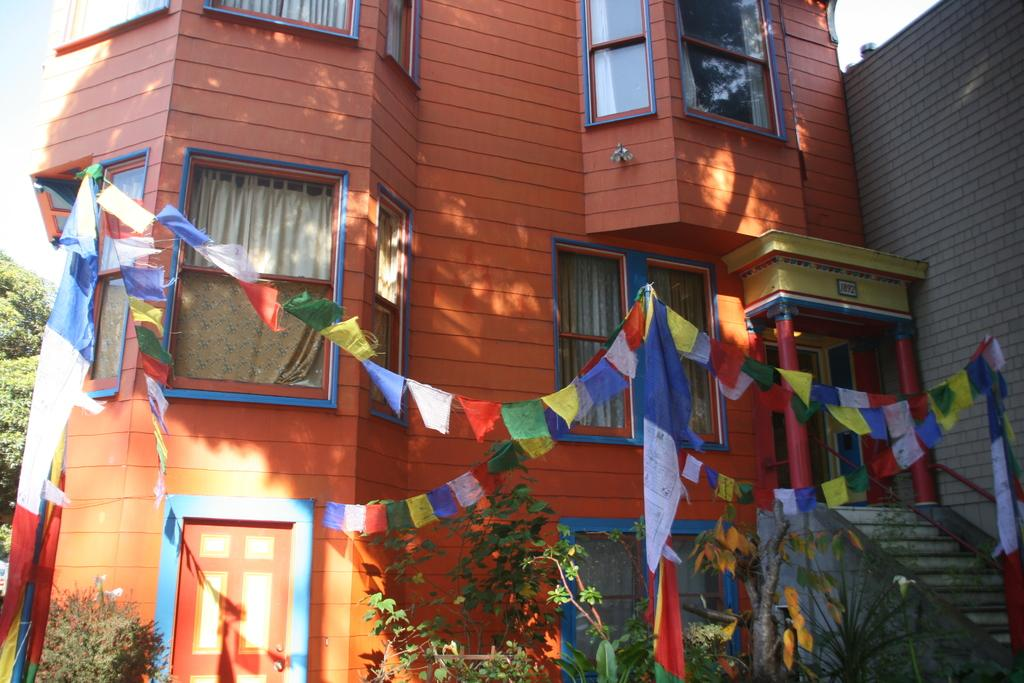What is located in the foreground of the image? There are flags and bunting flags in the foreground of the image. What can be seen in the background of the image? There is a building, stairs, a door, plants, trees, and the sky visible in the background of the image. What type of beef is being used to flavor the flags in the image? There is no beef or flavor mentioned in the image; it features flags and bunting flags in the foreground and various elements in the background. 